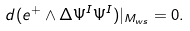<formula> <loc_0><loc_0><loc_500><loc_500>d ( e ^ { + } \wedge \Delta \Psi ^ { I } \Psi ^ { I } ) | _ { M _ { w s } } = 0 .</formula> 